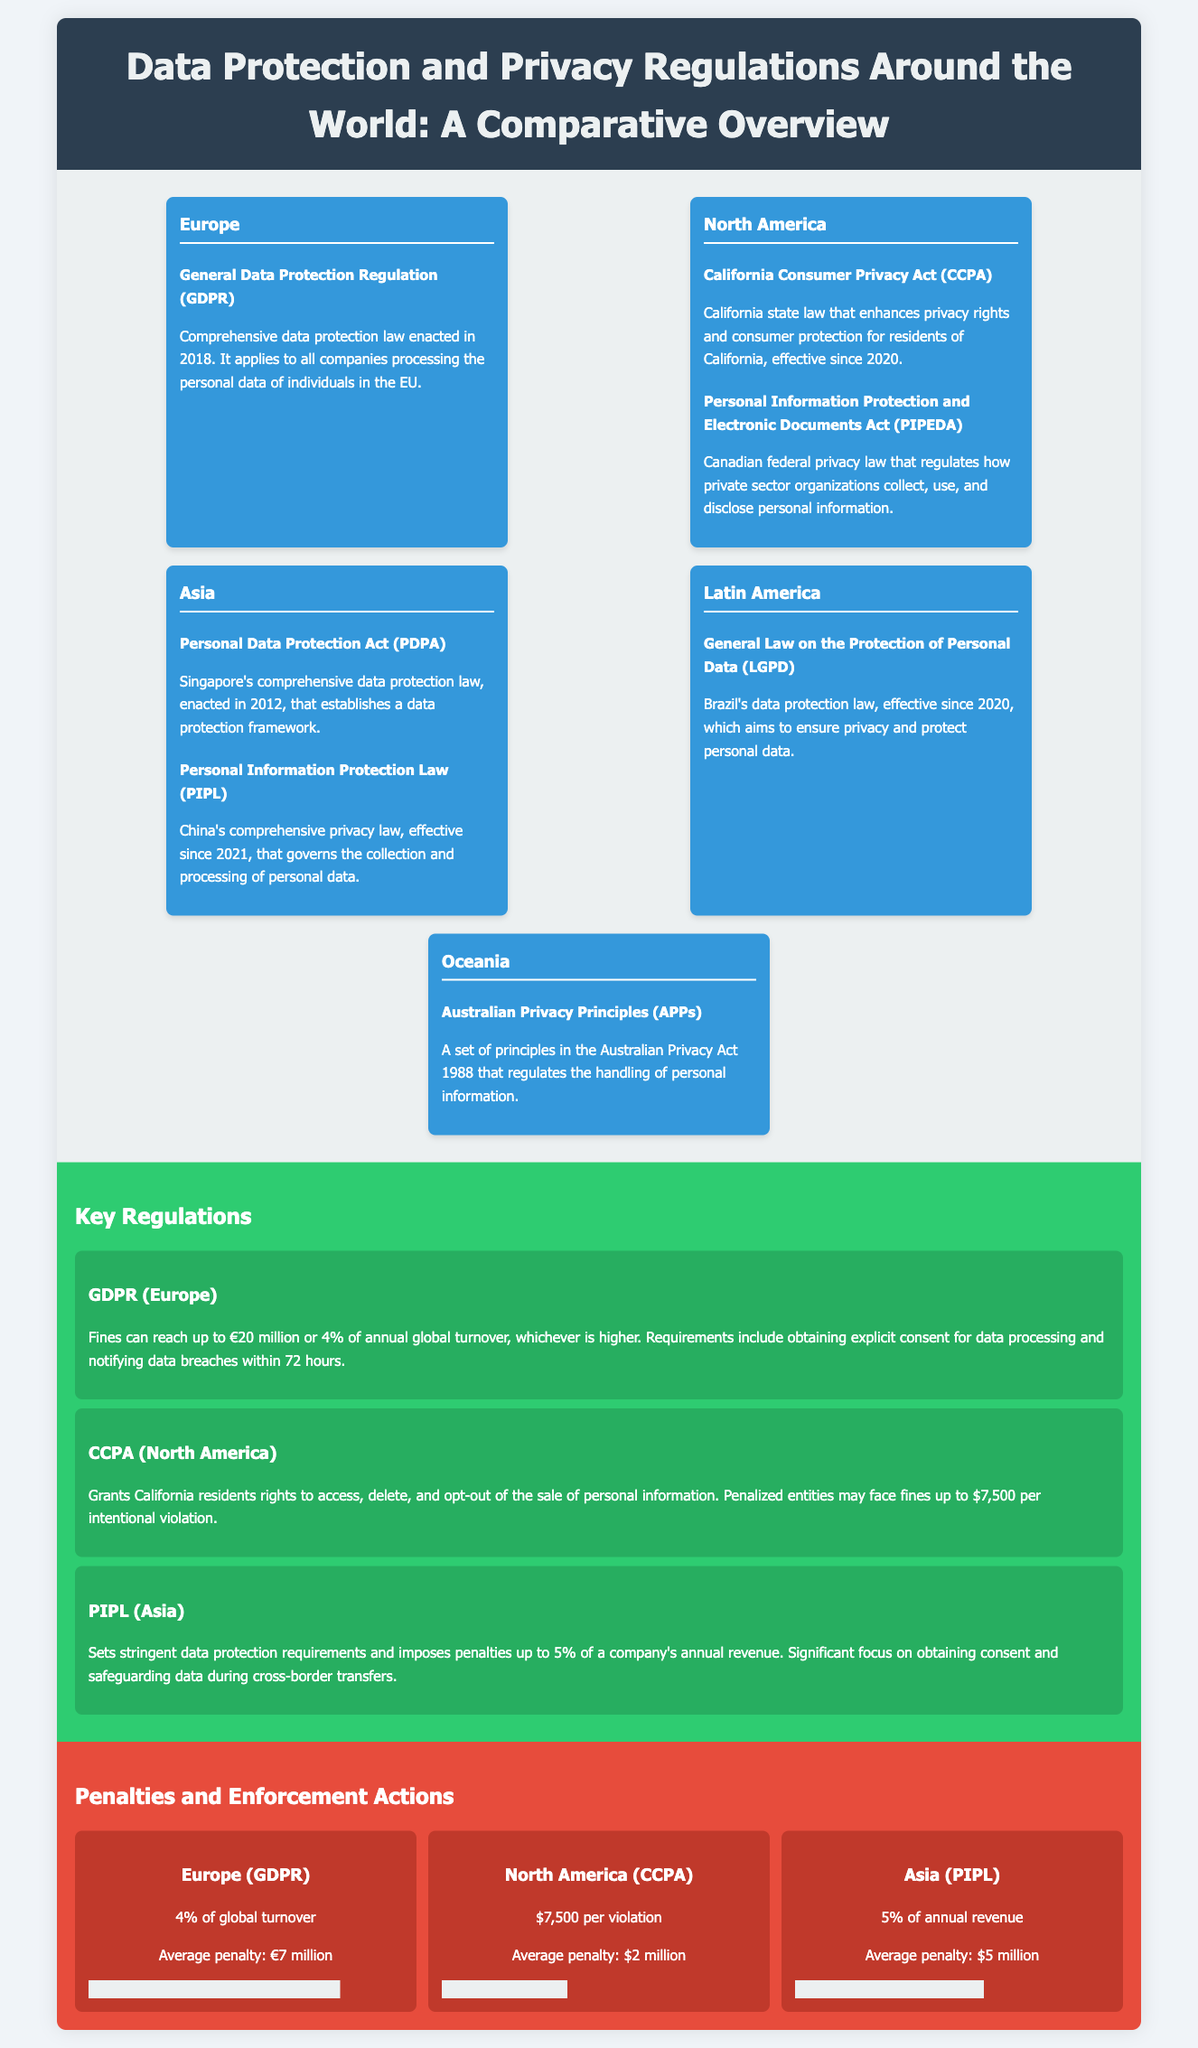What is the comprehensive data protection law in Europe? The document states that the General Data Protection Regulation (GDPR) is the comprehensive data protection law in Europe.
Answer: GDPR When was GDPR enacted? According to the infographic, GDPR was enacted in 2018.
Answer: 2018 What rights does the CCPA grant California residents? The document mentions that CCPA grants rights to access, delete, and opt-out of the sale of personal information.
Answer: Access, delete, opt-out What is the maximum penalty under GDPR? The document specifies that fines under GDPR can reach up to €20 million or 4% of annual global turnover, whichever is higher.
Answer: €20 million or 4% of annual global turnover Which country has the Personal Information Protection Law (PIPL)? The infographic indicates that PIPL is a law in China.
Answer: China How much is the average penalty under CCPA? The average penalty specified for CCPA in the document is $2 million.
Answer: $2 million What year did PIPL become effective? The document mentions that PIPL became effective since 2021.
Answer: 2021 What percentage of annual revenue can be penalized under PIPL? The document states that penalties under PIPL can reach up to 5% of annual revenue.
Answer: 5% What is the penalty for intentional violations under CCPA? According to the infographic, entities may face fines of up to $7,500 per intentional violation under CCPA.
Answer: $7,500 